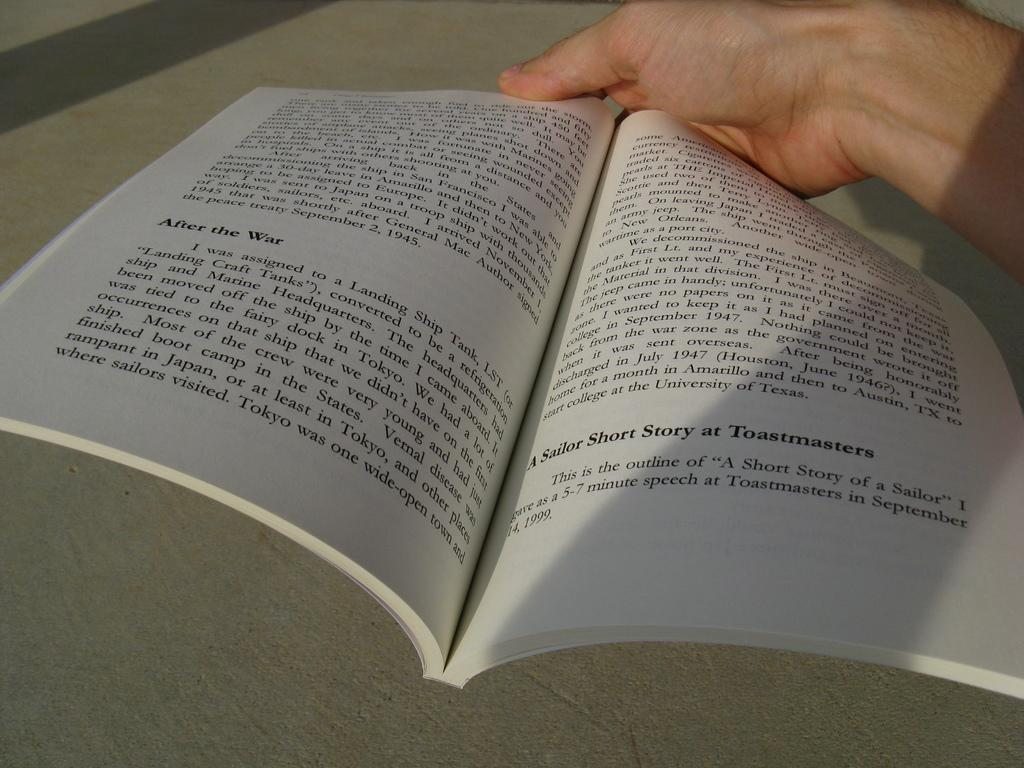What is the main subject in the foreground of the image? There is a person in the foreground of the image. What is the person holding in the image? The person is holding a book. What type of surface is visible in the image? There is a floor visible in the image. How many dimes can be seen on the seat in the image? There is no seat or dimes present in the image. What type of bell is visible in the image? There is no bell present in the image. 